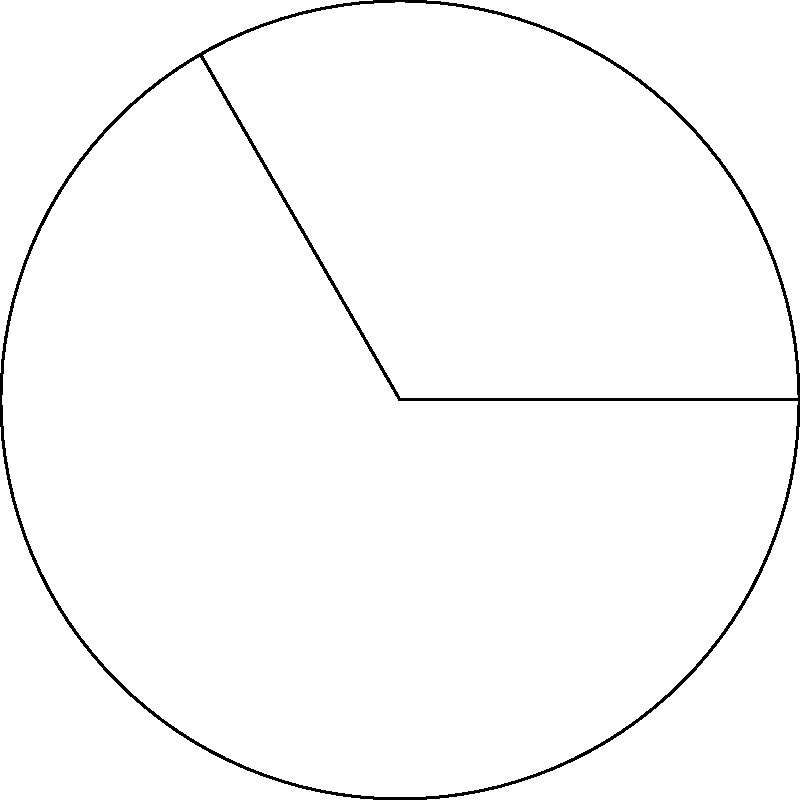In the circular sector shown, the radius of the circle is 6 cm and the central angle is 120°. Calculate the area of the sector to the nearest square centimeter. Let's approach this step-by-step:

1) The formula for the area of a circular sector is:

   $$A = \frac{\theta}{360°} \pi r^2$$

   where $A$ is the area, $\theta$ is the central angle in degrees, and $r$ is the radius.

2) We're given:
   - Radius $r = 6$ cm
   - Central angle $\theta = 120°$

3) Let's substitute these values into our formula:

   $$A = \frac{120°}{360°} \pi (6\text{ cm})^2$$

4) Simplify the fraction:

   $$A = \frac{1}{3} \pi (36\text{ cm}^2)$$

5) Multiply:

   $$A = 12\pi \text{ cm}^2$$

6) Use 3.14159 as an approximation for $\pi$:

   $$A \approx 12 * 3.14159 \text{ cm}^2 = 37.69908 \text{ cm}^2$$

7) Rounding to the nearest square centimeter:

   $$A \approx 38 \text{ cm}^2$$
Answer: 38 cm² 